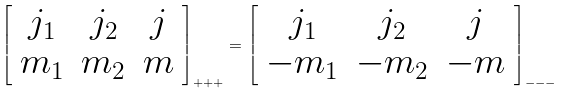Convert formula to latex. <formula><loc_0><loc_0><loc_500><loc_500>\left [ \begin{array} { c c c } j _ { 1 } & j _ { 2 } & j \\ m _ { 1 } & m _ { 2 } & m \end{array} \right ] _ { + + + } = \left [ \begin{array} { c c c } j _ { 1 } & j _ { 2 } & j \\ - m _ { 1 } & - m _ { 2 } & - m \end{array} \right ] _ { - - - }</formula> 